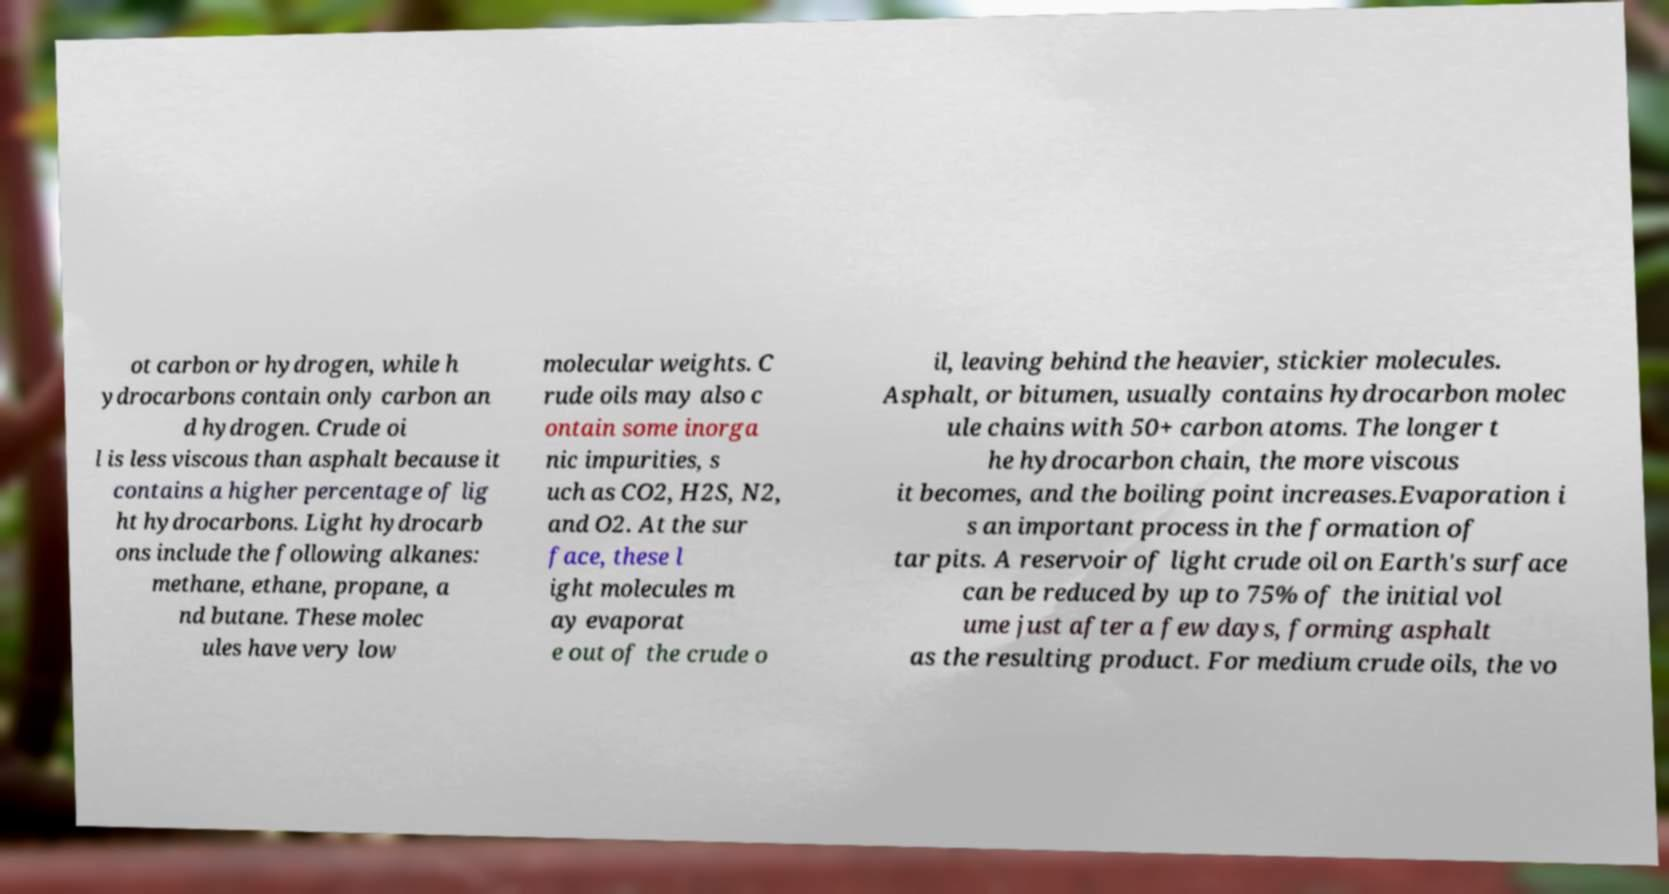For documentation purposes, I need the text within this image transcribed. Could you provide that? ot carbon or hydrogen, while h ydrocarbons contain only carbon an d hydrogen. Crude oi l is less viscous than asphalt because it contains a higher percentage of lig ht hydrocarbons. Light hydrocarb ons include the following alkanes: methane, ethane, propane, a nd butane. These molec ules have very low molecular weights. C rude oils may also c ontain some inorga nic impurities, s uch as CO2, H2S, N2, and O2. At the sur face, these l ight molecules m ay evaporat e out of the crude o il, leaving behind the heavier, stickier molecules. Asphalt, or bitumen, usually contains hydrocarbon molec ule chains with 50+ carbon atoms. The longer t he hydrocarbon chain, the more viscous it becomes, and the boiling point increases.Evaporation i s an important process in the formation of tar pits. A reservoir of light crude oil on Earth's surface can be reduced by up to 75% of the initial vol ume just after a few days, forming asphalt as the resulting product. For medium crude oils, the vo 